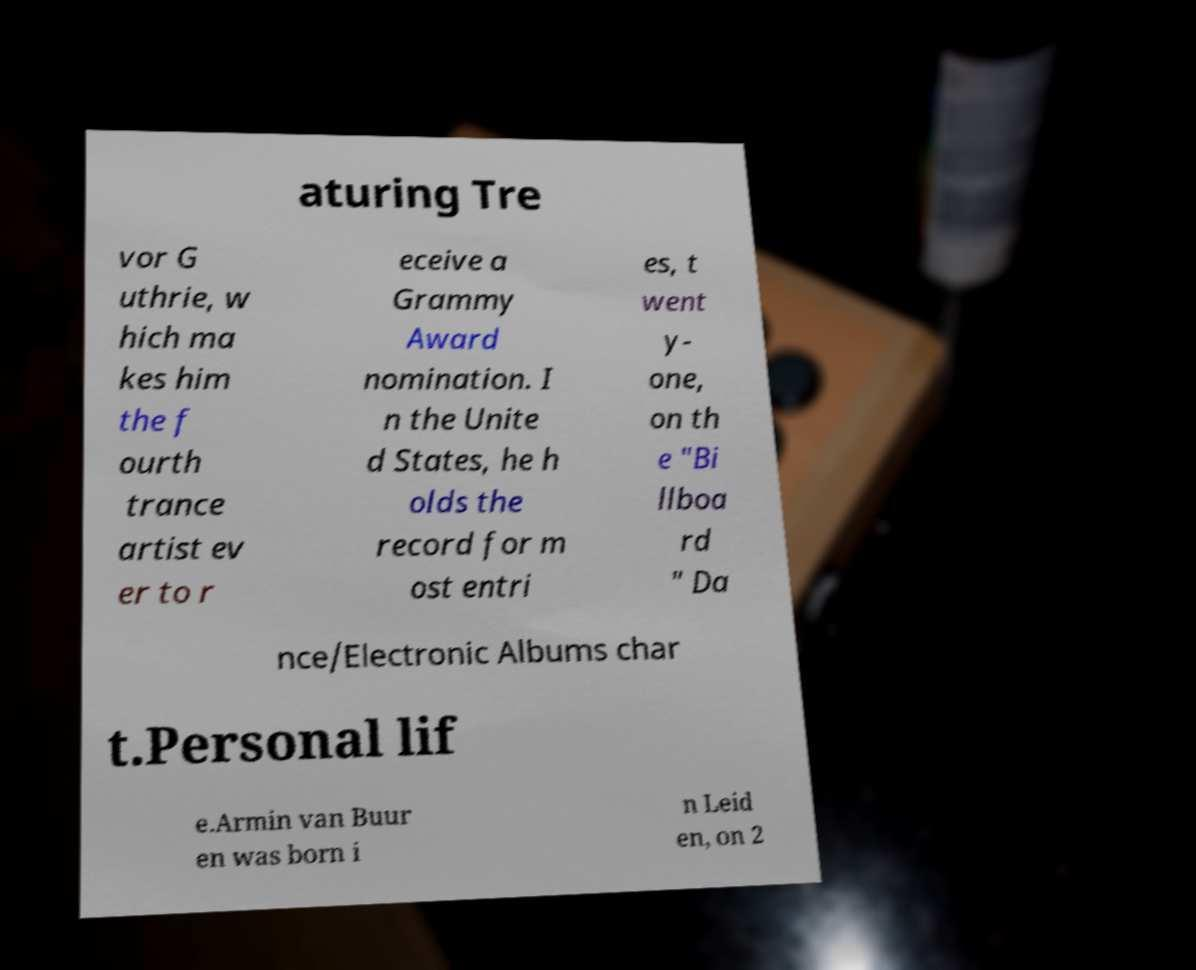Could you assist in decoding the text presented in this image and type it out clearly? aturing Tre vor G uthrie, w hich ma kes him the f ourth trance artist ev er to r eceive a Grammy Award nomination. I n the Unite d States, he h olds the record for m ost entri es, t went y- one, on th e "Bi llboa rd " Da nce/Electronic Albums char t.Personal lif e.Armin van Buur en was born i n Leid en, on 2 